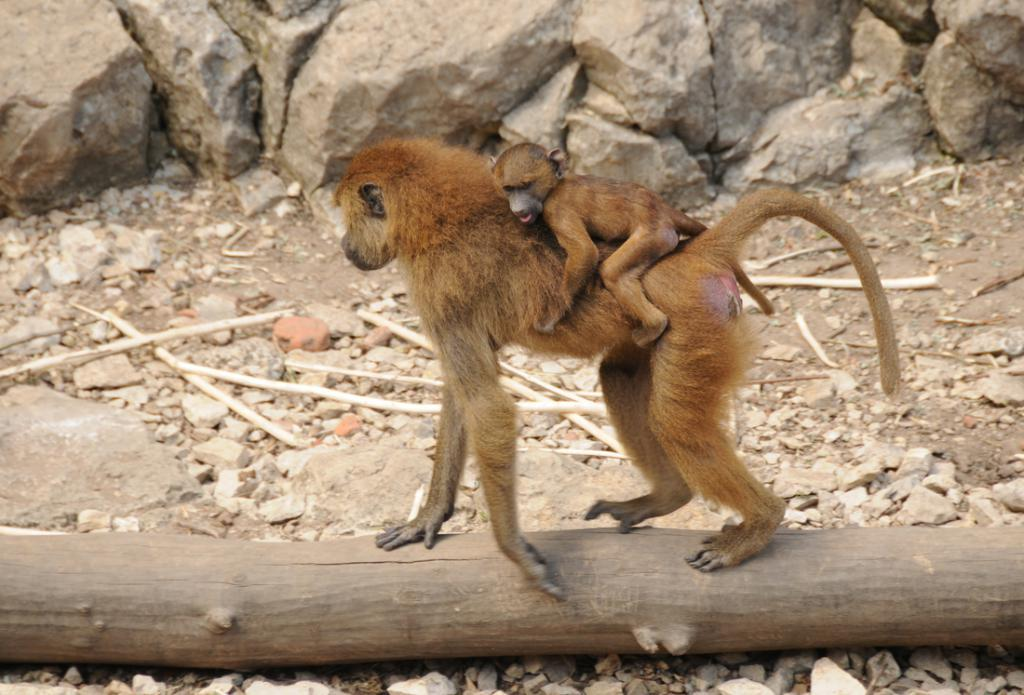What animal is the main subject of the image? There is a monkey in the image. What is the monkey doing in the image? The monkey is holding its baby. What surface is the monkey standing on? The monkey is standing on wood. What other objects can be seen in the image? There are stones and sticks in the image. What type of berry is the monkey eating in the image? There is no berry present in the image, and the monkey is not shown eating anything. 